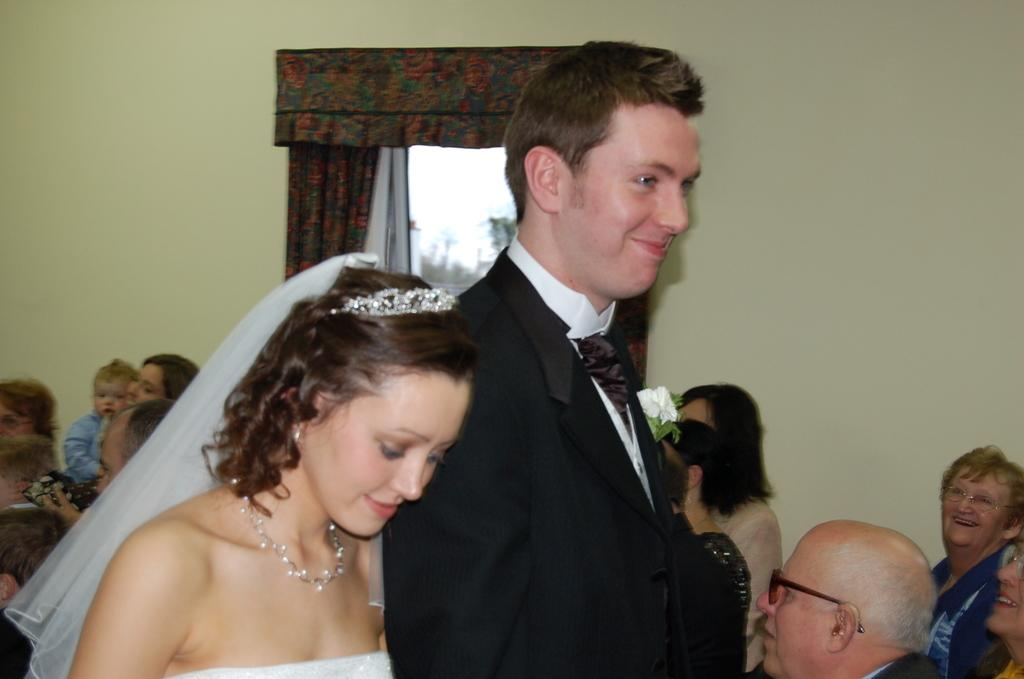Who are the main subjects in the image? There is a bride and groom in the image. Where are the bride and groom located in the image? They are standing in the middle of the image. What can be seen in the background of the image? There are many people sitting on chairs in the background. Can you describe the location of the chairs in relation to the window? The chairs are in front of a window. What is the appearance of the window? The window has curtains. What type of loaf is being served on the shelf in the image? There is no loaf or shelf present in the image. Where did the bride and groom go on their vacation after the event in the image? The image does not provide any information about a vacation or the bride and groom's plans after the event. 